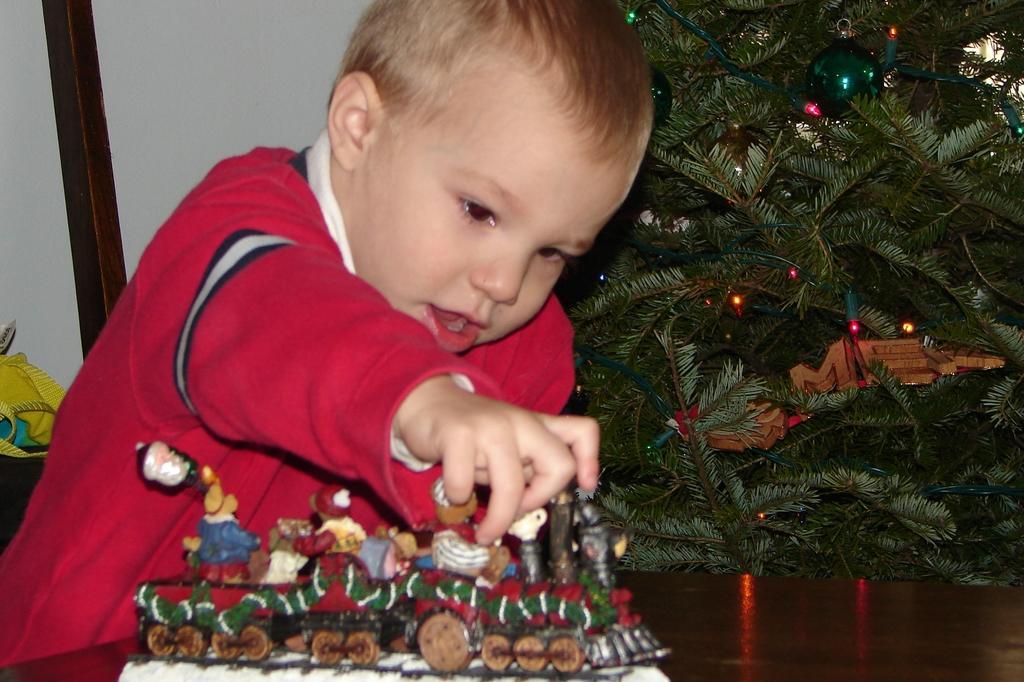In one or two sentences, can you explain what this image depicts? In this image, I can see a boy holding a toy, which is on a wooden object. I can see a tree with lights and decorative items. On the left side of the image, there is an object. In the background, I can see the wall. 